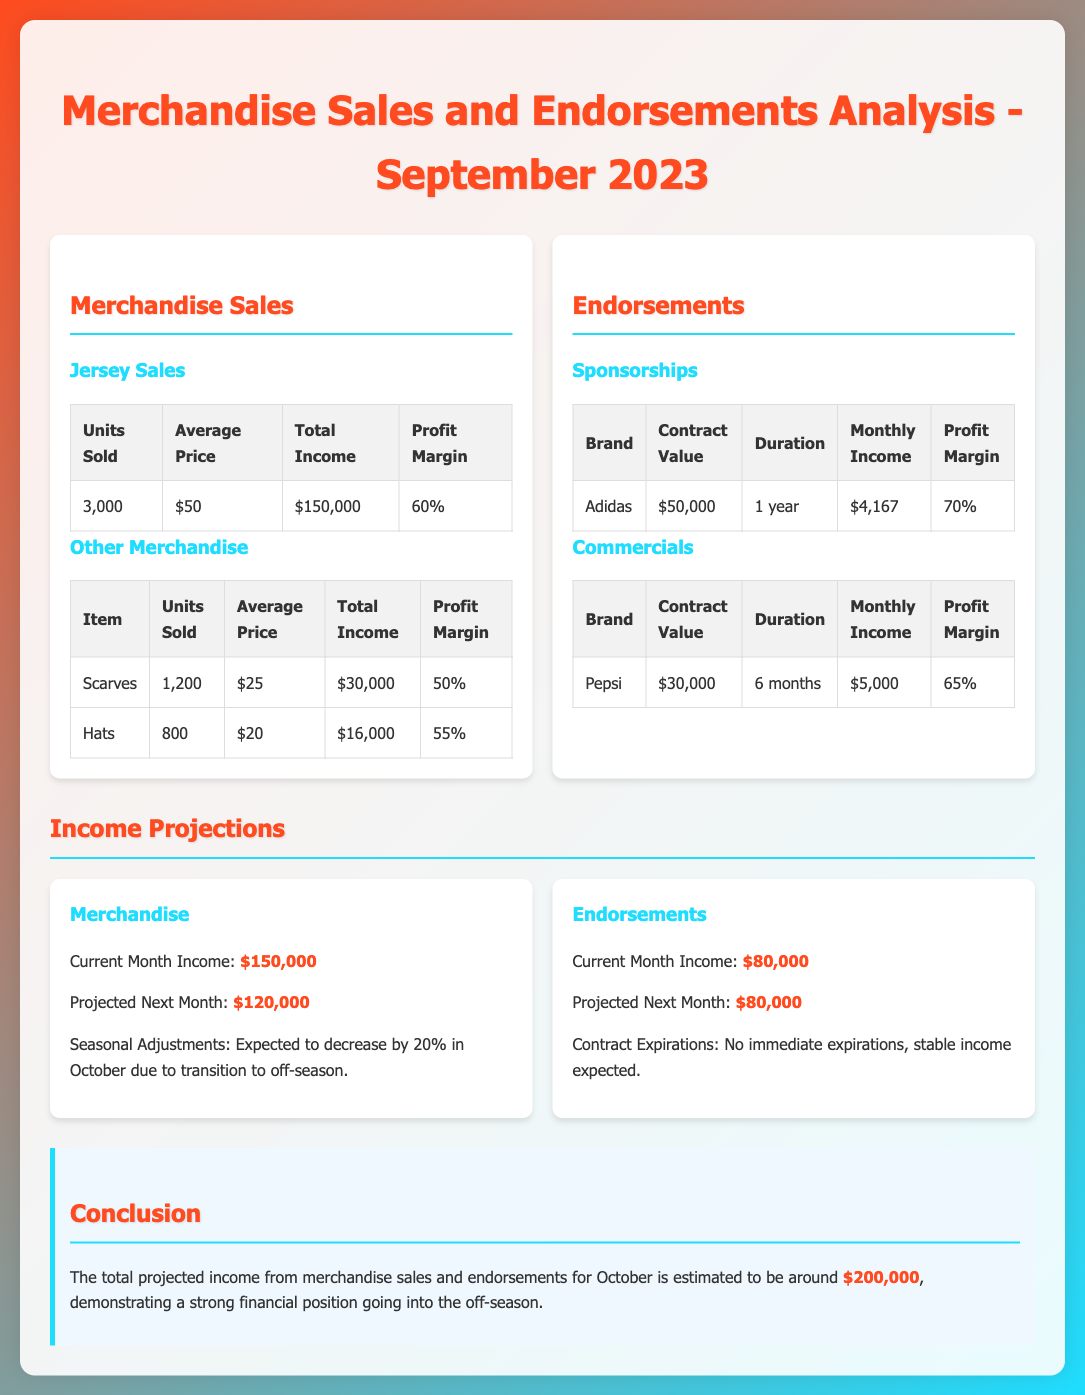What was the total income from jersey sales? The total income from jersey sales is listed in the document under merchandise sales as $150,000.
Answer: $150,000 How many units of scarves were sold? The number of scarves sold is specified in the merchandise section of the document as 1,200 units.
Answer: 1,200 What is the profit margin for Adidas sponsorship? The profit margin for the Adidas sponsorship is stated as 70% in the endorsements section.
Answer: 70% What is the projected income for next month from merchandise? The projected income for next month from merchandise sales is mentioned as $120,000.
Answer: $120,000 What is the total projected income from merchandise sales and endorsements for October? The total projected income for October combining merchandise sales and endorsements is estimated in the conclusion section as $200,000.
Answer: $200,000 What is the average price of a hat sold? The average price of a hat is specified in the document as $20.
Answer: $20 How many units of hats were sold? The document states that 800 units of hats were sold.
Answer: 800 What is the total income from Pepsi commercials? The total income from Pepsi commercials is stated as $5,000 in the endorsements section.
Answer: $5,000 What percentage decrease is expected in merchandise sales for October? The expected percentage decrease in merchandise sales for October is mentioned as 20%.
Answer: 20% 